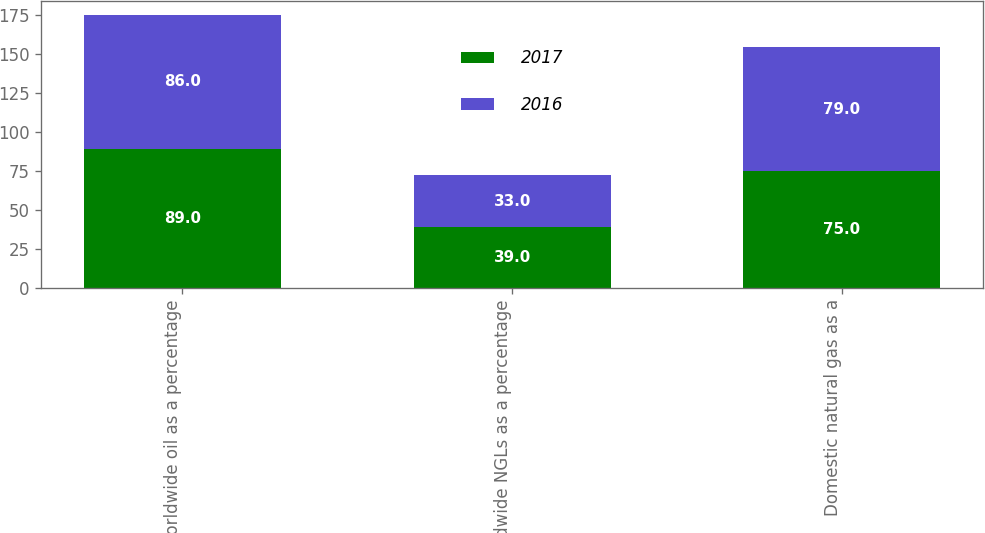Convert chart to OTSL. <chart><loc_0><loc_0><loc_500><loc_500><stacked_bar_chart><ecel><fcel>Worldwide oil as a percentage<fcel>Worldwide NGLs as a percentage<fcel>Domestic natural gas as a<nl><fcel>2017<fcel>89<fcel>39<fcel>75<nl><fcel>2016<fcel>86<fcel>33<fcel>79<nl></chart> 